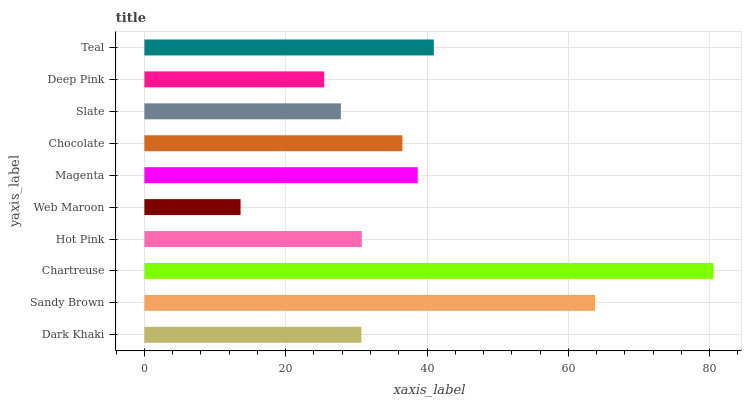Is Web Maroon the minimum?
Answer yes or no. Yes. Is Chartreuse the maximum?
Answer yes or no. Yes. Is Sandy Brown the minimum?
Answer yes or no. No. Is Sandy Brown the maximum?
Answer yes or no. No. Is Sandy Brown greater than Dark Khaki?
Answer yes or no. Yes. Is Dark Khaki less than Sandy Brown?
Answer yes or no. Yes. Is Dark Khaki greater than Sandy Brown?
Answer yes or no. No. Is Sandy Brown less than Dark Khaki?
Answer yes or no. No. Is Chocolate the high median?
Answer yes or no. Yes. Is Hot Pink the low median?
Answer yes or no. Yes. Is Dark Khaki the high median?
Answer yes or no. No. Is Chocolate the low median?
Answer yes or no. No. 